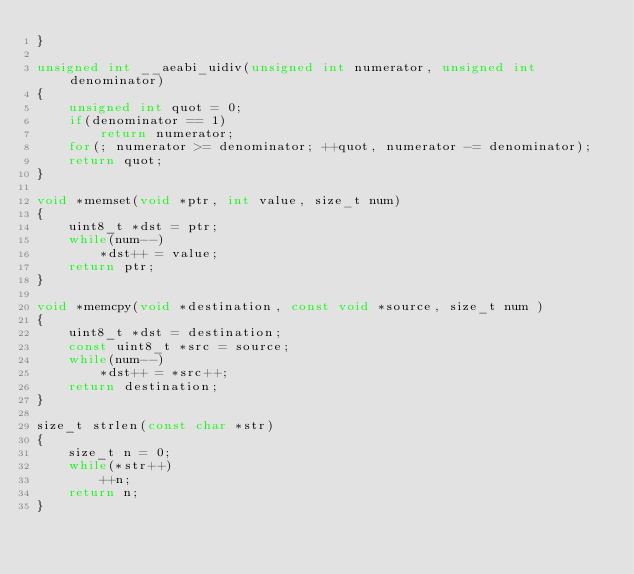<code> <loc_0><loc_0><loc_500><loc_500><_C_>}

unsigned int __aeabi_uidiv(unsigned int numerator, unsigned int denominator)
{
    unsigned int quot = 0;
    if(denominator == 1)
        return numerator;
    for(; numerator >= denominator; ++quot, numerator -= denominator);
    return quot;
}

void *memset(void *ptr, int value, size_t num)
{
    uint8_t *dst = ptr;
    while(num--)
        *dst++ = value;
    return ptr;
}

void *memcpy(void *destination, const void *source, size_t num )
{
    uint8_t *dst = destination;
    const uint8_t *src = source;
    while(num--)
        *dst++ = *src++;
    return destination;
}

size_t strlen(const char *str)
{
    size_t n = 0;
    while(*str++)
        ++n;
    return n;
}

</code> 